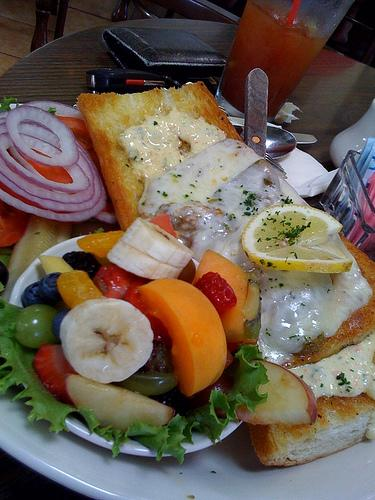What color are the onions on the top left part of the white plate? Please explain your reasoning. purple. These are called red onions but are actually this color 